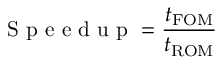<formula> <loc_0><loc_0><loc_500><loc_500>S p e e d u p = \frac { t _ { F O M } } { t _ { R O M } }</formula> 